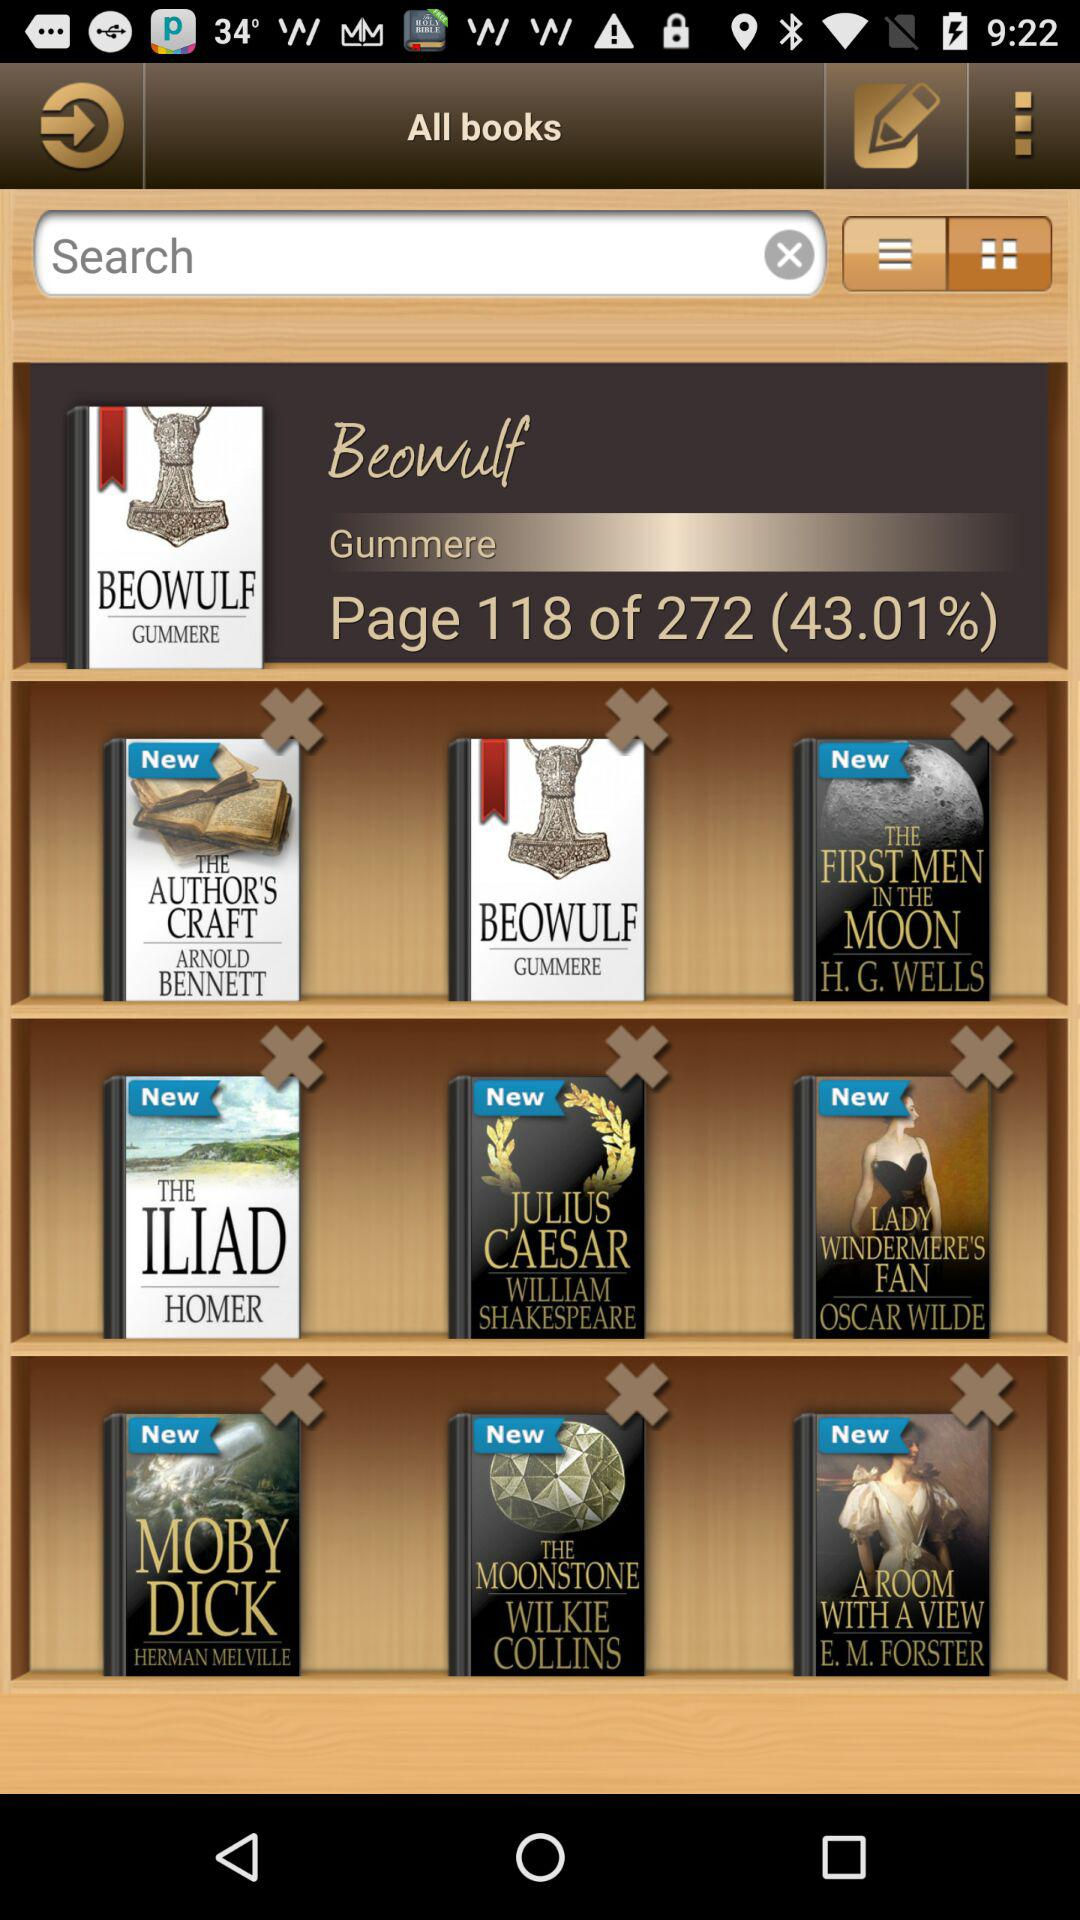Which are the different books available in "All Books"? The different books available in "All Books" are "THE AUTHOR'S CRAFT", "BEOWULF", "THE FIRST MEN IN THE MOON", "THE ILIAD", "JULIUS CAESAR", "LADY WINDERMERE'S FAN", "MOBY DICK", "THE MOONSTONE" and "A ROOM WITH A VIEW". 